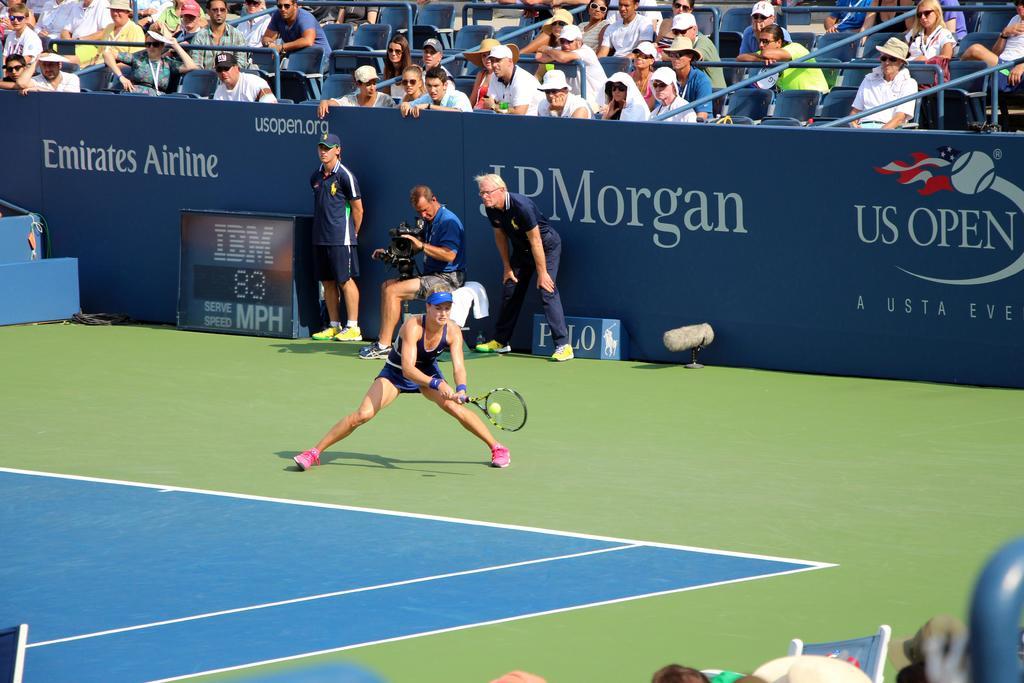Can you describe this image briefly? This is the picture of the stadium. There is a person standing and holding bat and she is playing and there is a person sitting behind the woman and he is holding camera. At the back there are group of people sitting, and there is a hoarding and there is a screen at the bottom. 